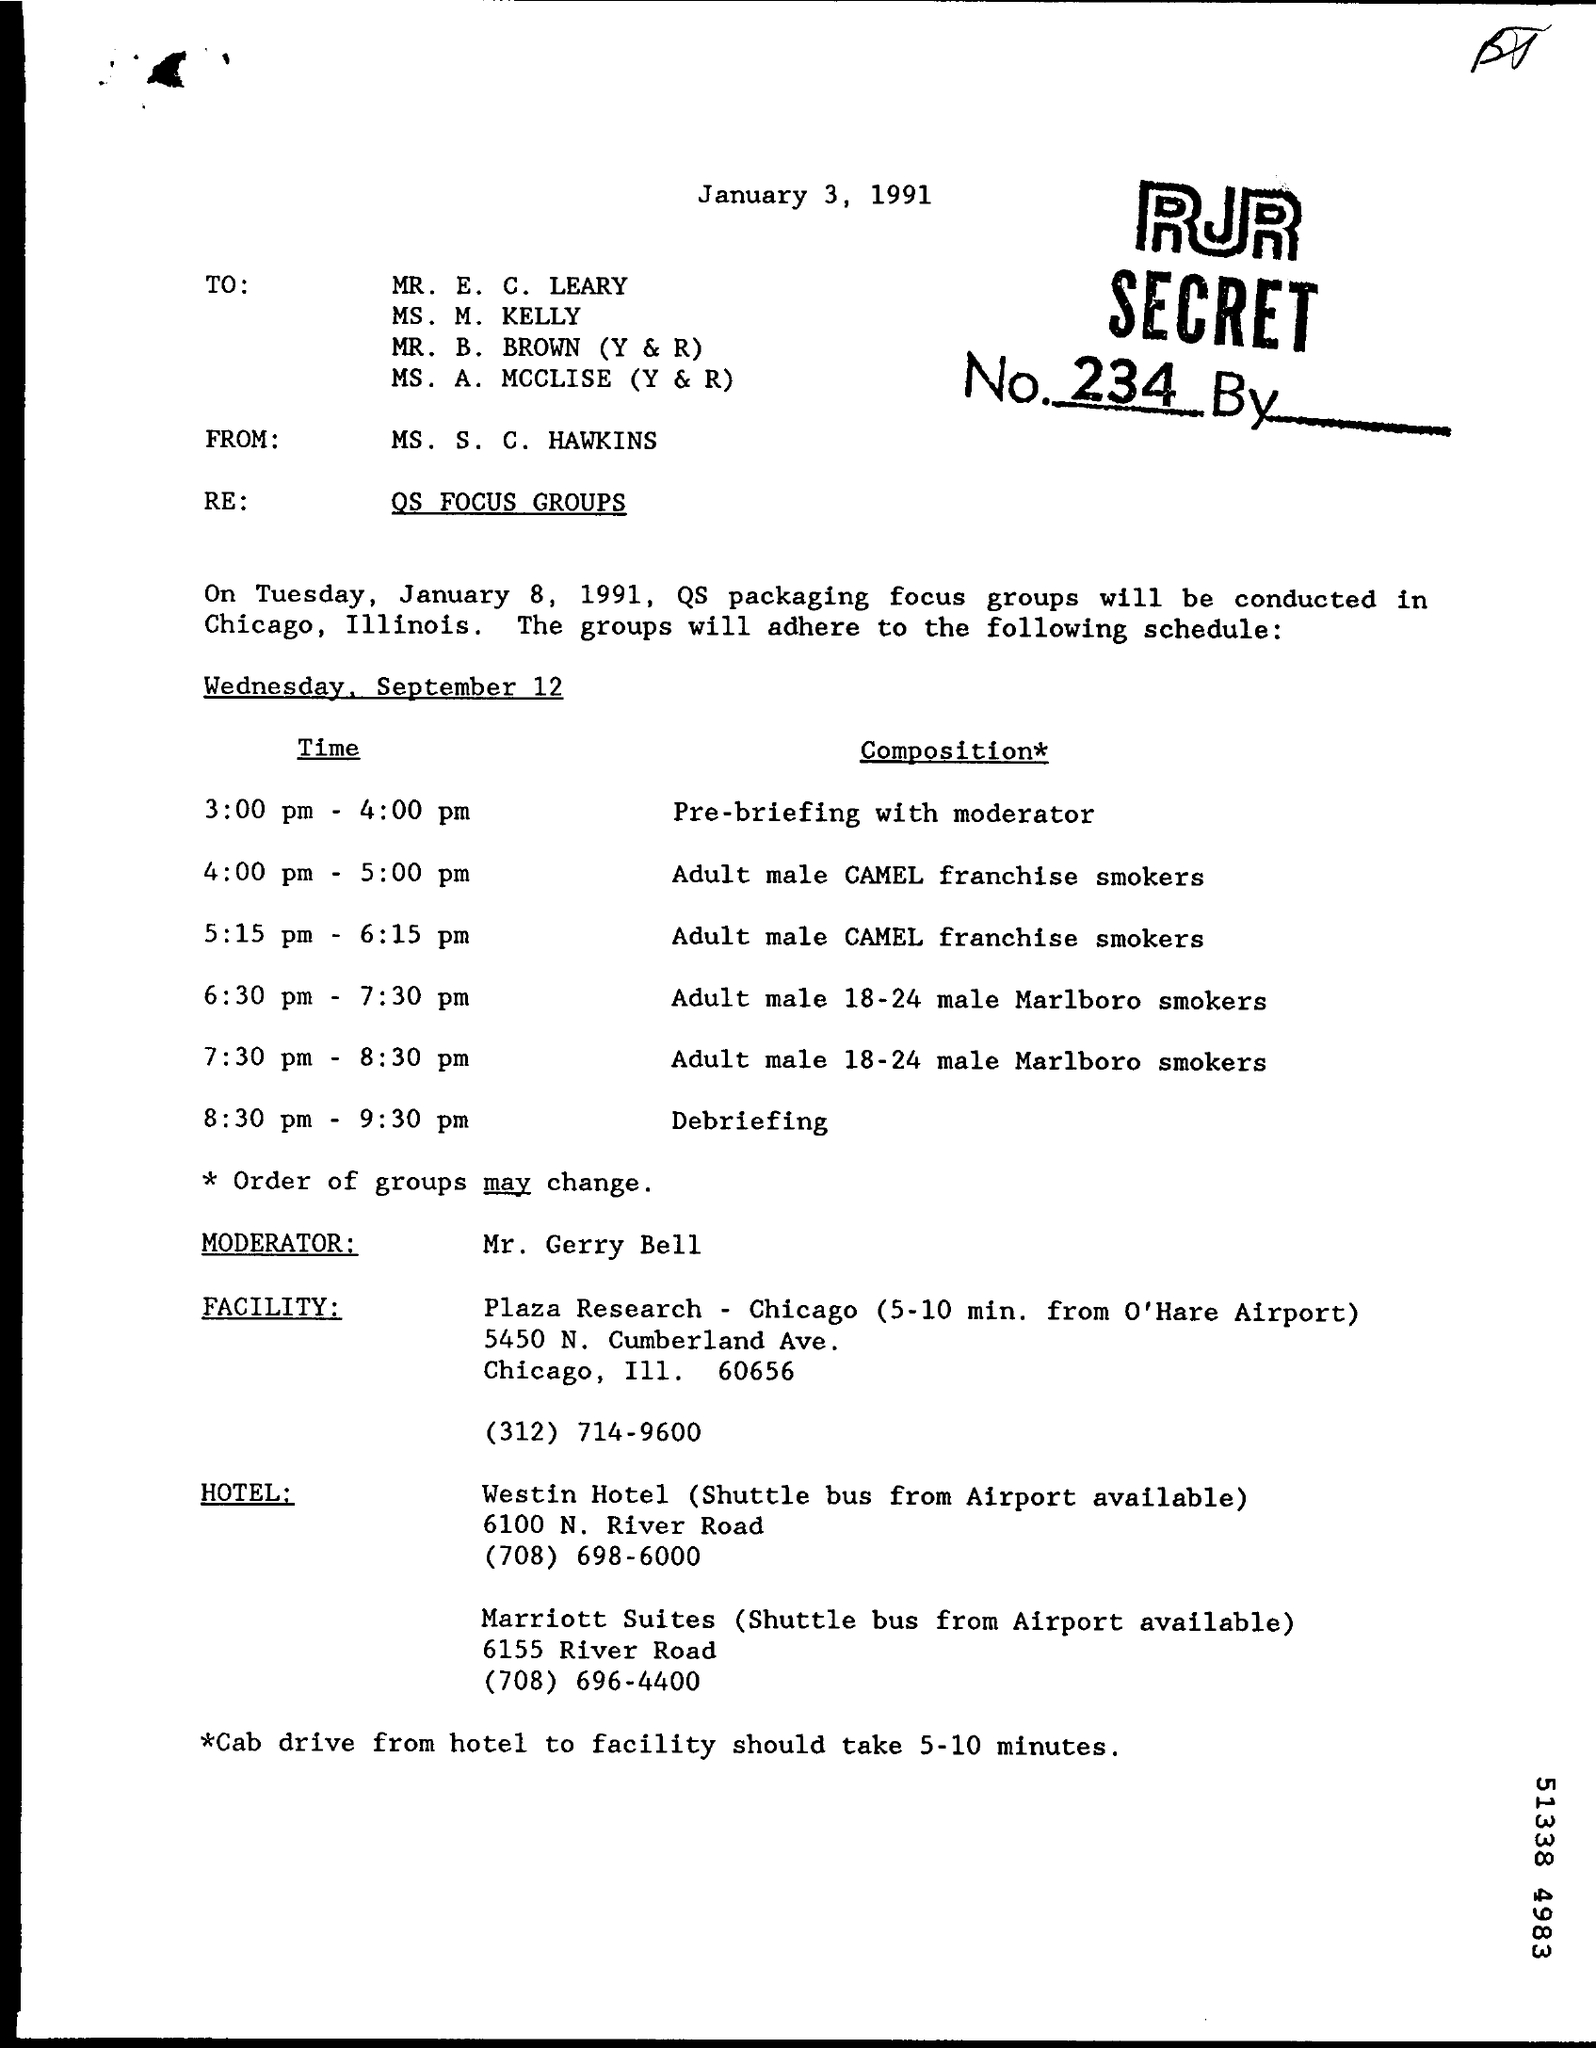When is the letter dated on?
Ensure brevity in your answer.  January 3, 1991. When will the QC packaging focus groups be conducted?
Offer a terse response. January 8, 1991. Where will the QC packaging focus groups be conducted?
Offer a very short reply. Illinois. Who is the Moderator?
Give a very brief answer. Mr. Gerry Bell. What time is the Debriefing?
Make the answer very short. 8:30 pm - 9:30 pm. Which is the Facilty?
Your answer should be compact. Plaza Research - Chicago. What time is the pre-briefing with moderator?
Provide a short and direct response. 3:00 pm - 4:00 pm. What is the phone no. for marriott suites?
Ensure brevity in your answer.  (708) 696-4400. 